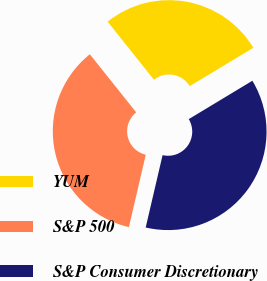Convert chart. <chart><loc_0><loc_0><loc_500><loc_500><pie_chart><fcel>YUM<fcel>S&P 500<fcel>S&P Consumer Discretionary<nl><fcel>27.08%<fcel>35.63%<fcel>37.29%<nl></chart> 